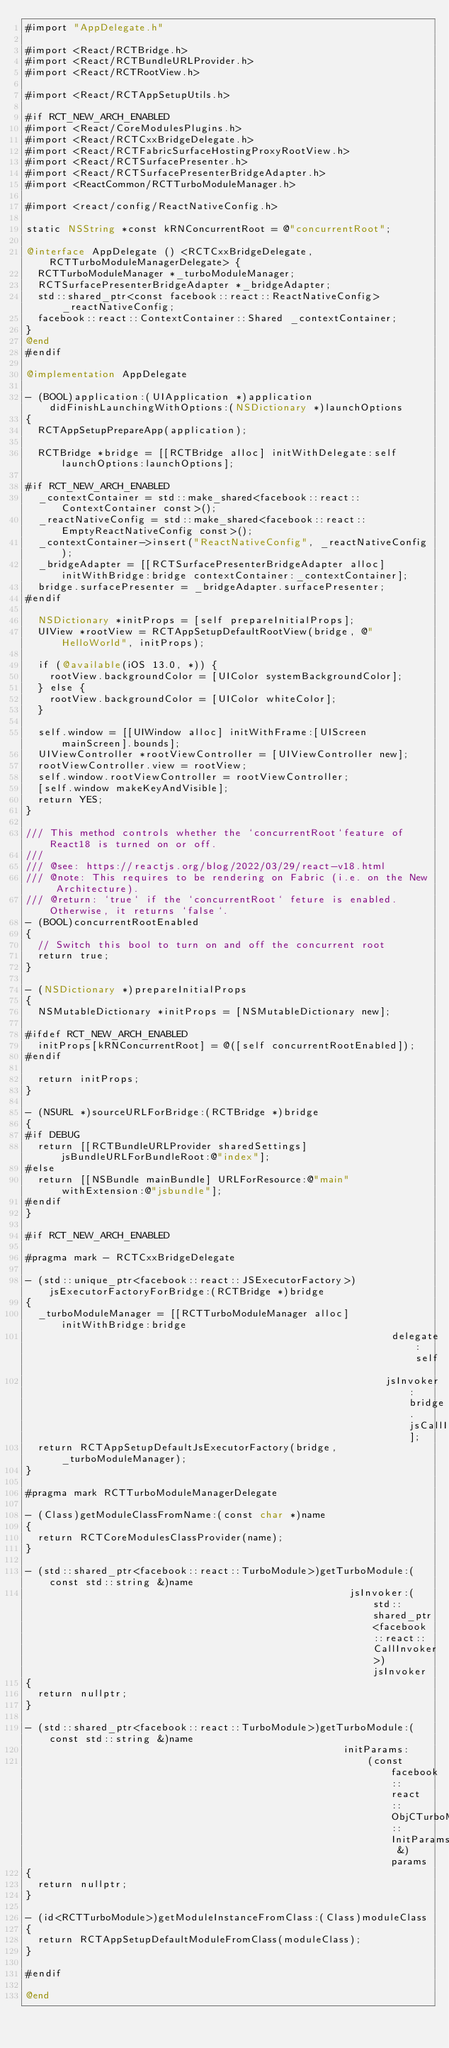<code> <loc_0><loc_0><loc_500><loc_500><_ObjectiveC_>#import "AppDelegate.h"

#import <React/RCTBridge.h>
#import <React/RCTBundleURLProvider.h>
#import <React/RCTRootView.h>

#import <React/RCTAppSetupUtils.h>

#if RCT_NEW_ARCH_ENABLED
#import <React/CoreModulesPlugins.h>
#import <React/RCTCxxBridgeDelegate.h>
#import <React/RCTFabricSurfaceHostingProxyRootView.h>
#import <React/RCTSurfacePresenter.h>
#import <React/RCTSurfacePresenterBridgeAdapter.h>
#import <ReactCommon/RCTTurboModuleManager.h>

#import <react/config/ReactNativeConfig.h>

static NSString *const kRNConcurrentRoot = @"concurrentRoot";

@interface AppDelegate () <RCTCxxBridgeDelegate, RCTTurboModuleManagerDelegate> {
  RCTTurboModuleManager *_turboModuleManager;
  RCTSurfacePresenterBridgeAdapter *_bridgeAdapter;
  std::shared_ptr<const facebook::react::ReactNativeConfig> _reactNativeConfig;
  facebook::react::ContextContainer::Shared _contextContainer;
}
@end
#endif

@implementation AppDelegate

- (BOOL)application:(UIApplication *)application didFinishLaunchingWithOptions:(NSDictionary *)launchOptions
{
  RCTAppSetupPrepareApp(application);

  RCTBridge *bridge = [[RCTBridge alloc] initWithDelegate:self launchOptions:launchOptions];

#if RCT_NEW_ARCH_ENABLED
  _contextContainer = std::make_shared<facebook::react::ContextContainer const>();
  _reactNativeConfig = std::make_shared<facebook::react::EmptyReactNativeConfig const>();
  _contextContainer->insert("ReactNativeConfig", _reactNativeConfig);
  _bridgeAdapter = [[RCTSurfacePresenterBridgeAdapter alloc] initWithBridge:bridge contextContainer:_contextContainer];
  bridge.surfacePresenter = _bridgeAdapter.surfacePresenter;
#endif

  NSDictionary *initProps = [self prepareInitialProps];
  UIView *rootView = RCTAppSetupDefaultRootView(bridge, @"HelloWorld", initProps);

  if (@available(iOS 13.0, *)) {
    rootView.backgroundColor = [UIColor systemBackgroundColor];
  } else {
    rootView.backgroundColor = [UIColor whiteColor];
  }

  self.window = [[UIWindow alloc] initWithFrame:[UIScreen mainScreen].bounds];
  UIViewController *rootViewController = [UIViewController new];
  rootViewController.view = rootView;
  self.window.rootViewController = rootViewController;
  [self.window makeKeyAndVisible];
  return YES;
}

/// This method controls whether the `concurrentRoot`feature of React18 is turned on or off.
///
/// @see: https://reactjs.org/blog/2022/03/29/react-v18.html
/// @note: This requires to be rendering on Fabric (i.e. on the New Architecture).
/// @return: `true` if the `concurrentRoot` feture is enabled. Otherwise, it returns `false`.
- (BOOL)concurrentRootEnabled
{
  // Switch this bool to turn on and off the concurrent root
  return true;
}

- (NSDictionary *)prepareInitialProps
{
  NSMutableDictionary *initProps = [NSMutableDictionary new];

#ifdef RCT_NEW_ARCH_ENABLED
  initProps[kRNConcurrentRoot] = @([self concurrentRootEnabled]);
#endif

  return initProps;
}

- (NSURL *)sourceURLForBridge:(RCTBridge *)bridge
{
#if DEBUG
  return [[RCTBundleURLProvider sharedSettings] jsBundleURLForBundleRoot:@"index"];
#else
  return [[NSBundle mainBundle] URLForResource:@"main" withExtension:@"jsbundle"];
#endif
}

#if RCT_NEW_ARCH_ENABLED

#pragma mark - RCTCxxBridgeDelegate

- (std::unique_ptr<facebook::react::JSExecutorFactory>)jsExecutorFactoryForBridge:(RCTBridge *)bridge
{
  _turboModuleManager = [[RCTTurboModuleManager alloc] initWithBridge:bridge
                                                             delegate:self
                                                            jsInvoker:bridge.jsCallInvoker];
  return RCTAppSetupDefaultJsExecutorFactory(bridge, _turboModuleManager);
}

#pragma mark RCTTurboModuleManagerDelegate

- (Class)getModuleClassFromName:(const char *)name
{
  return RCTCoreModulesClassProvider(name);
}

- (std::shared_ptr<facebook::react::TurboModule>)getTurboModule:(const std::string &)name
                                                      jsInvoker:(std::shared_ptr<facebook::react::CallInvoker>)jsInvoker
{
  return nullptr;
}

- (std::shared_ptr<facebook::react::TurboModule>)getTurboModule:(const std::string &)name
                                                     initParams:
                                                         (const facebook::react::ObjCTurboModule::InitParams &)params
{
  return nullptr;
}

- (id<RCTTurboModule>)getModuleInstanceFromClass:(Class)moduleClass
{
  return RCTAppSetupDefaultModuleFromClass(moduleClass);
}

#endif

@end
</code> 